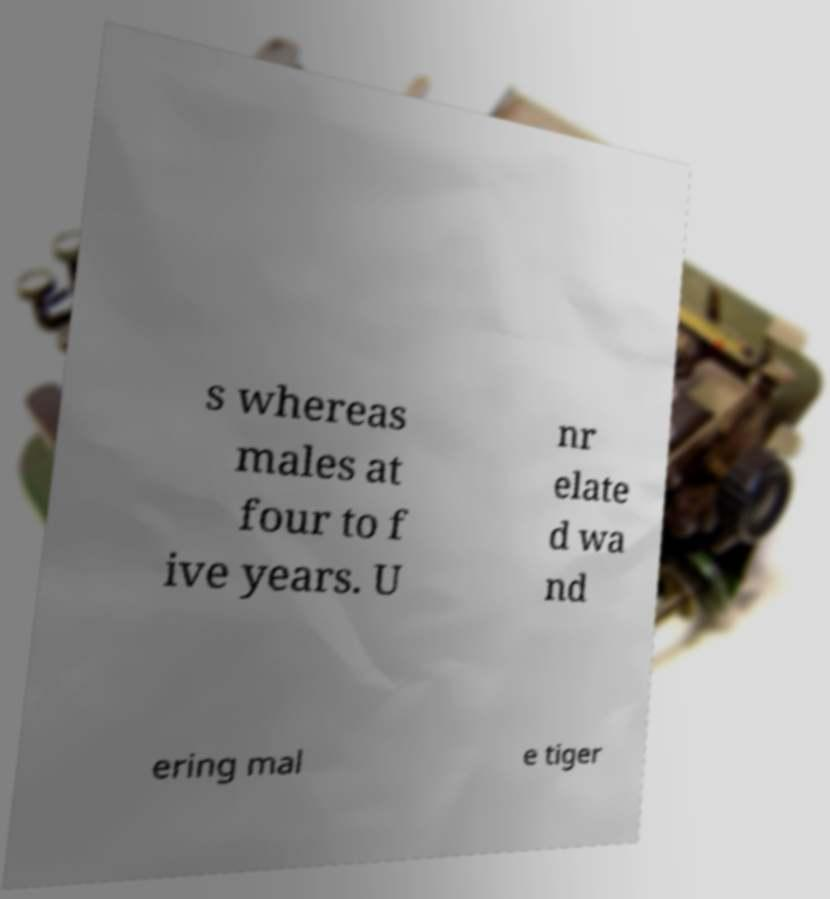Could you extract and type out the text from this image? s whereas males at four to f ive years. U nr elate d wa nd ering mal e tiger 